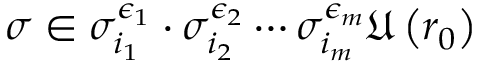Convert formula to latex. <formula><loc_0><loc_0><loc_500><loc_500>\sigma \in \sigma _ { i _ { 1 } } ^ { \epsilon _ { 1 } } \cdot \sigma _ { i _ { 2 } } ^ { \epsilon _ { 2 } } \cdots \sigma _ { i _ { m } } ^ { \epsilon _ { m } } \mathfrak { U } \left ( r _ { 0 } \right )</formula> 